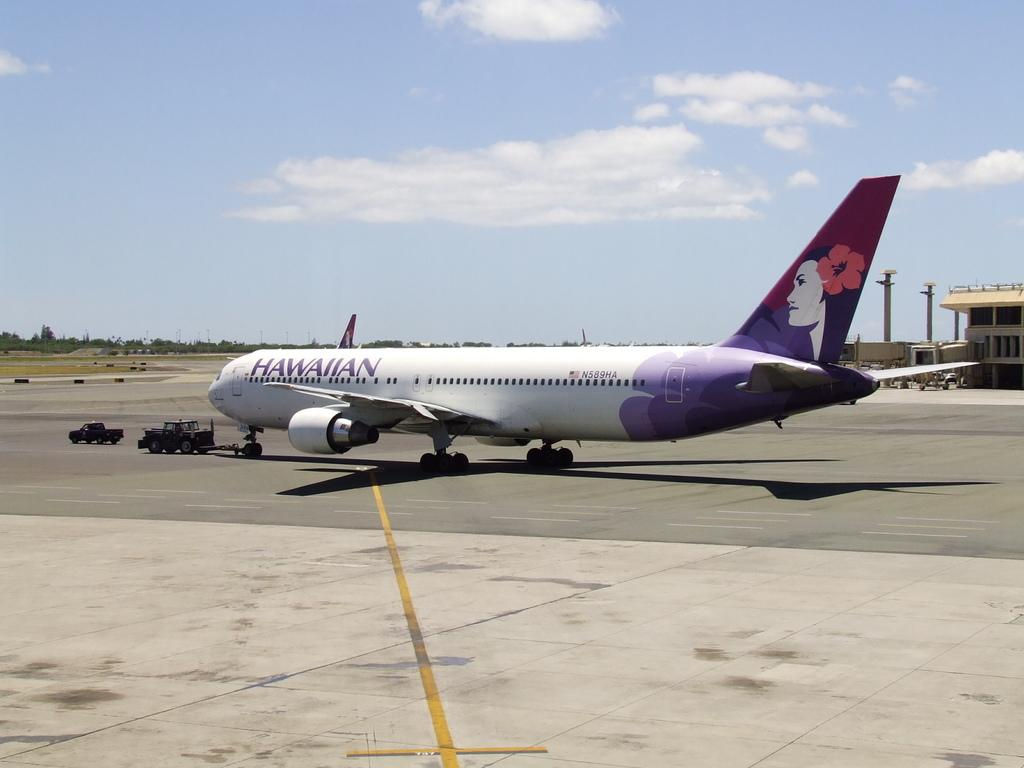Provide a one-sentence caption for the provided image. hawaiian airlines airplane with tow vehicle in front. 